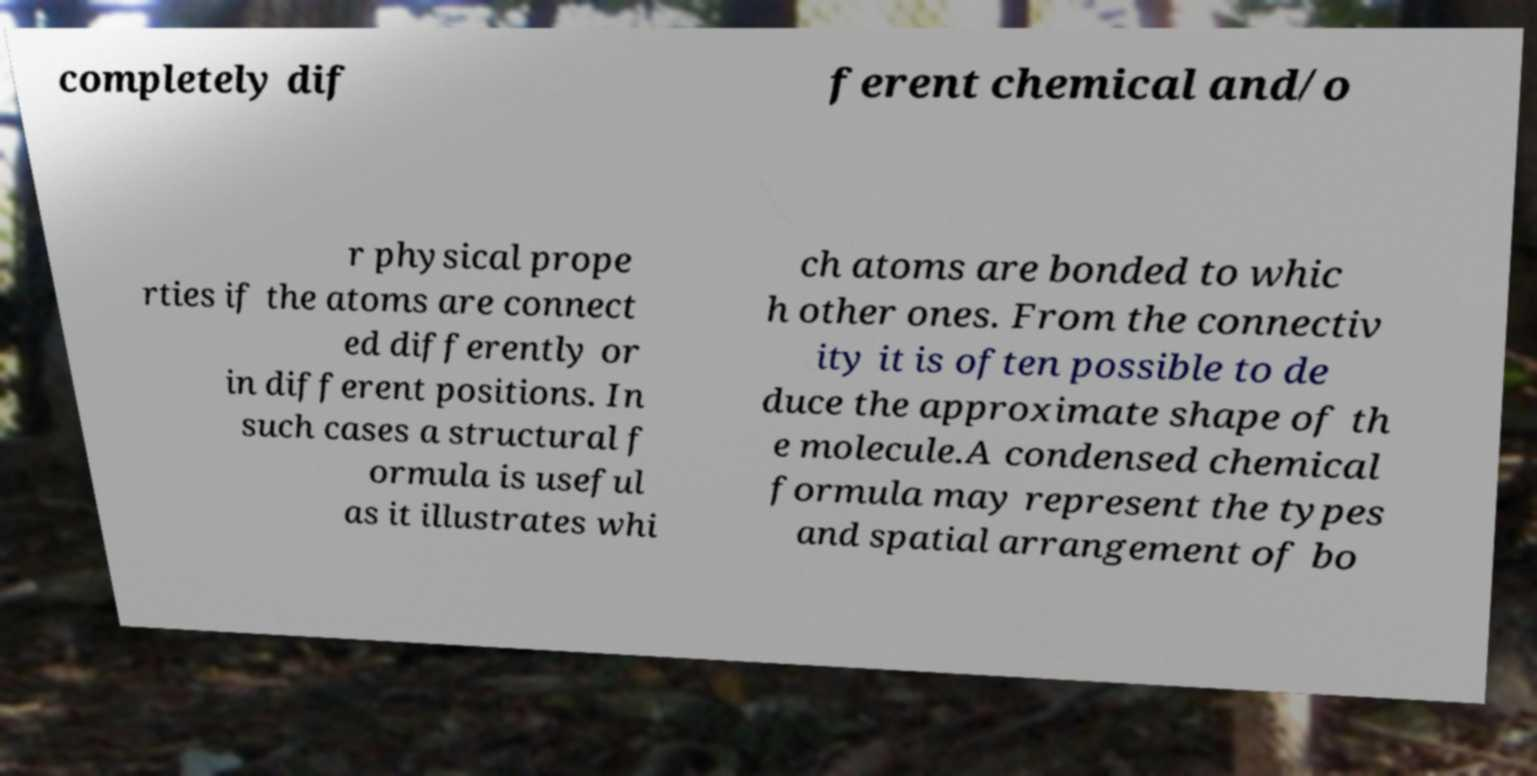Can you read and provide the text displayed in the image?This photo seems to have some interesting text. Can you extract and type it out for me? completely dif ferent chemical and/o r physical prope rties if the atoms are connect ed differently or in different positions. In such cases a structural f ormula is useful as it illustrates whi ch atoms are bonded to whic h other ones. From the connectiv ity it is often possible to de duce the approximate shape of th e molecule.A condensed chemical formula may represent the types and spatial arrangement of bo 